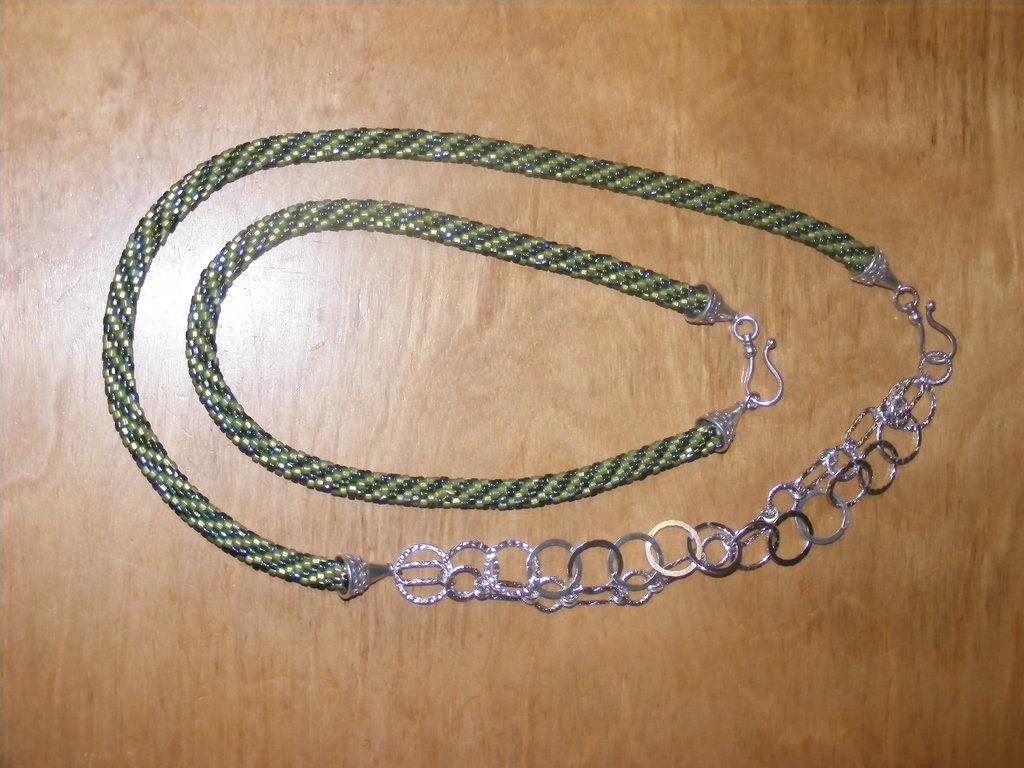Describe this image in one or two sentences. In the center of the image we can see chains placed on the table. 